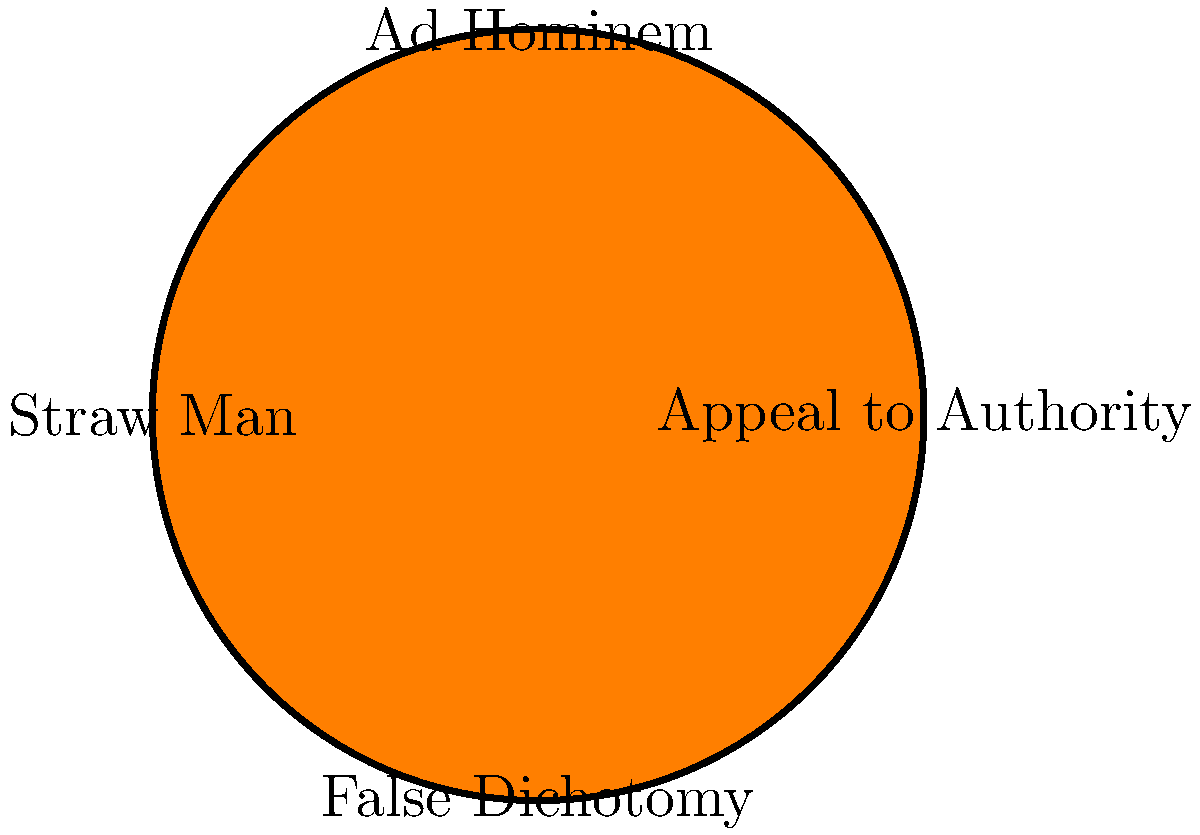As a seasoned college professor who has seen many students struggle with writing papers and dissertations, you're developing a lesson on logical fallacies. Using the provided cartoon representation, which logical fallacy would best describe the following argument:

"Dr. Smith, a renowned physicist, says climate change is not real. Therefore, climate change must not be happening." To identify the logical fallacy in this argument, let's analyze it step-by-step:

1. The argument presents Dr. Smith, a renowned physicist, as an authority figure.
2. It then uses Dr. Smith's opinion on climate change as the sole basis for concluding that climate change is not happening.
3. This argument relies entirely on Dr. Smith's authority as a physicist, rather than on scientific evidence or data about climate change.
4. The fallacy here is assuming that because Dr. Smith is an expert in physics, his opinion on climate change must be correct and authoritative.
5. This is a classic example of the "Appeal to Authority" fallacy.
6. The "Appeal to Authority" fallacy occurs when someone's authority or expertise is used as the primary basis for an argument, especially in areas outside their specific field of expertise.
7. In this case, while Dr. Smith may be a renowned physicist, climate science is a different field requiring specific expertise.
8. The argument fails to consider that even experts can be wrong, especially when speaking outside their area of specialization.
9. A more logical approach would be to examine the scientific evidence and consensus among climate scientists, rather than relying solely on one physicist's opinion.

Looking at the cartoon representation, we can see that "Appeal to Authority" is one of the logical fallacies depicted, which matches our analysis of the given argument.
Answer: Appeal to Authority 